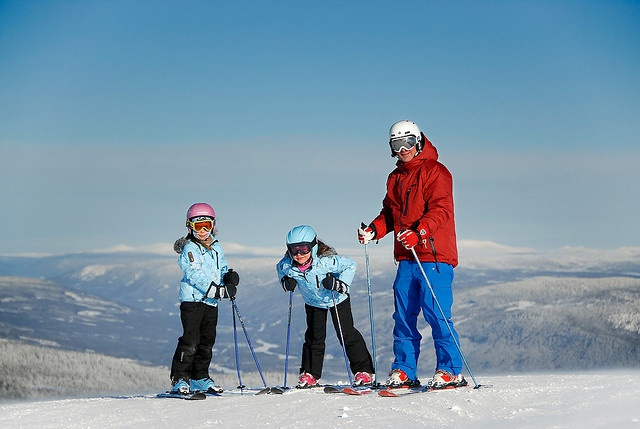Describe the objects in this image and their specific colors. I can see people in teal, brown, blue, and navy tones, people in teal, black, lightblue, and gray tones, people in teal, black, lightblue, and gray tones, skis in teal, black, lightgray, darkgray, and gray tones, and skis in teal, darkgray, lightgray, black, and gray tones in this image. 